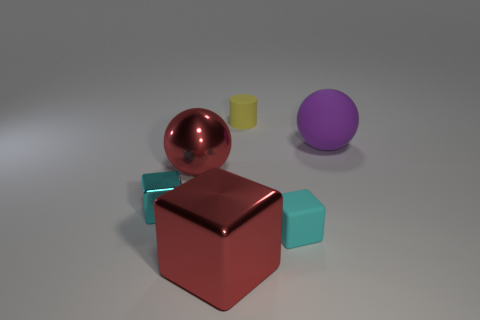Subtract all cyan blocks. How many were subtracted if there are1cyan blocks left? 1 Subtract all big red metallic blocks. How many blocks are left? 2 Add 1 yellow metallic spheres. How many objects exist? 7 Subtract all red spheres. How many spheres are left? 1 Subtract all cylinders. How many objects are left? 5 Subtract all red balls. Subtract all yellow cylinders. How many balls are left? 1 Subtract all gray cylinders. How many purple balls are left? 1 Subtract all blue cubes. Subtract all cyan objects. How many objects are left? 4 Add 1 large cubes. How many large cubes are left? 2 Add 3 large gray metal blocks. How many large gray metal blocks exist? 3 